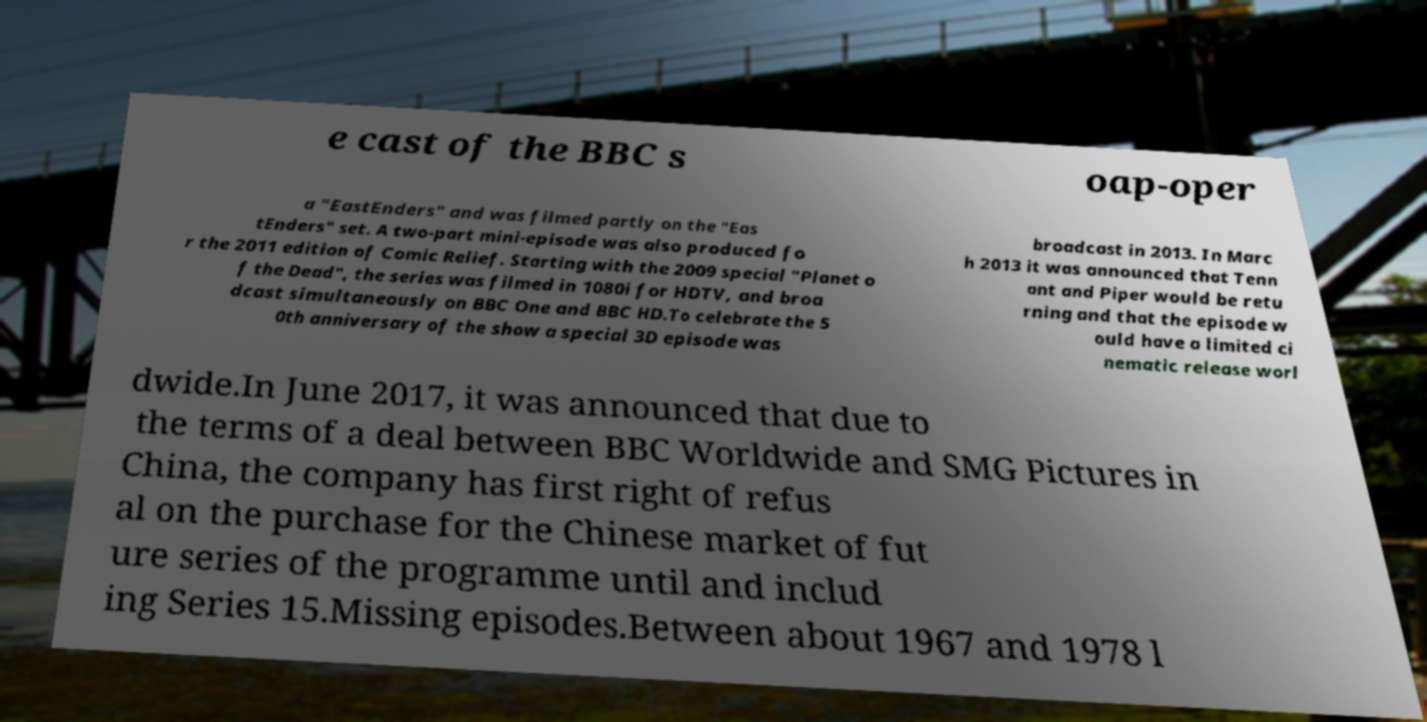Could you assist in decoding the text presented in this image and type it out clearly? e cast of the BBC s oap-oper a "EastEnders" and was filmed partly on the "Eas tEnders" set. A two-part mini-episode was also produced fo r the 2011 edition of Comic Relief. Starting with the 2009 special "Planet o f the Dead", the series was filmed in 1080i for HDTV, and broa dcast simultaneously on BBC One and BBC HD.To celebrate the 5 0th anniversary of the show a special 3D episode was broadcast in 2013. In Marc h 2013 it was announced that Tenn ant and Piper would be retu rning and that the episode w ould have a limited ci nematic release worl dwide.In June 2017, it was announced that due to the terms of a deal between BBC Worldwide and SMG Pictures in China, the company has first right of refus al on the purchase for the Chinese market of fut ure series of the programme until and includ ing Series 15.Missing episodes.Between about 1967 and 1978 l 